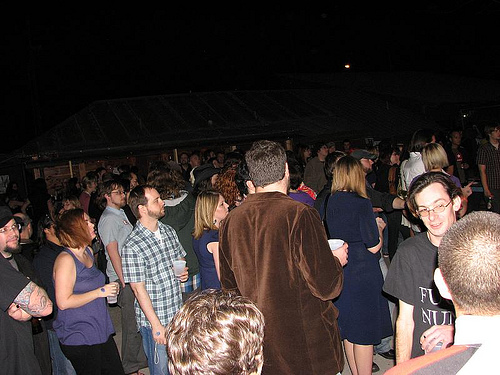<image>
Is there a person in the crowd? Yes. The person is contained within or inside the crowd, showing a containment relationship. 